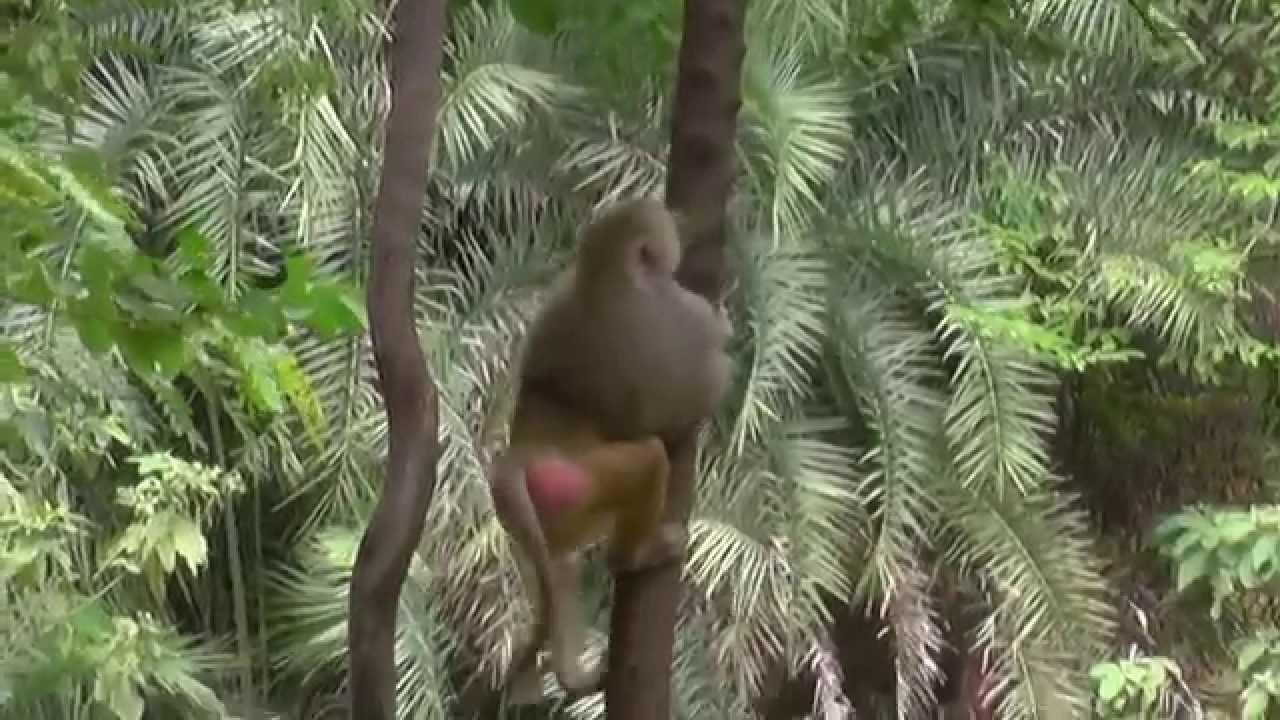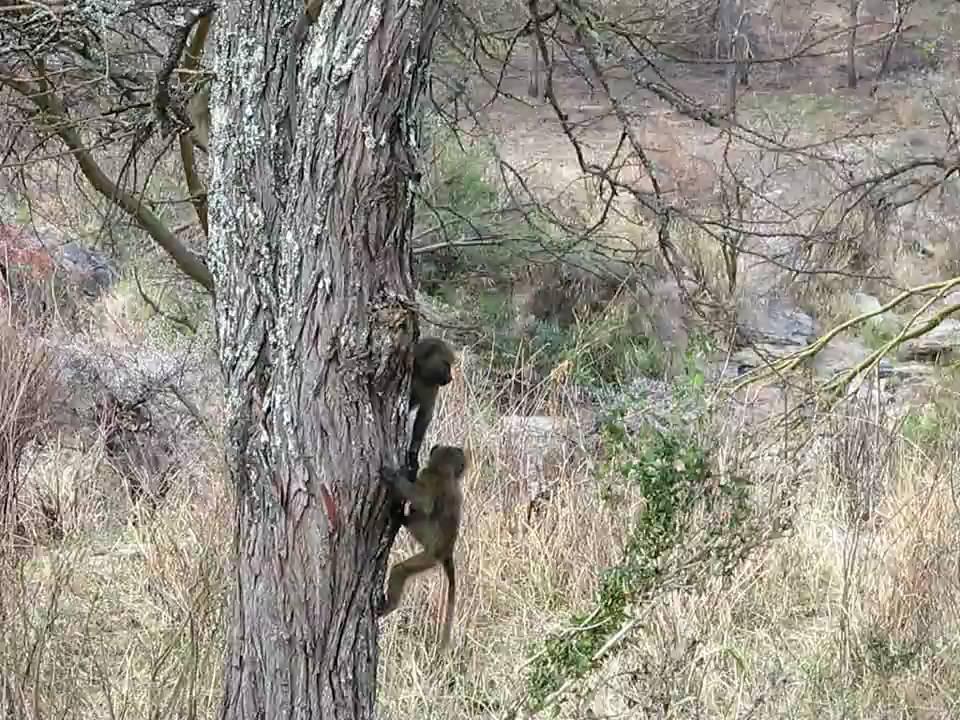The first image is the image on the left, the second image is the image on the right. Given the left and right images, does the statement "The monkeys are actively climbing trees." hold true? Answer yes or no. Yes. The first image is the image on the left, the second image is the image on the right. For the images shown, is this caption "at least two baboons are climbimg a tree in the image pair" true? Answer yes or no. Yes. 